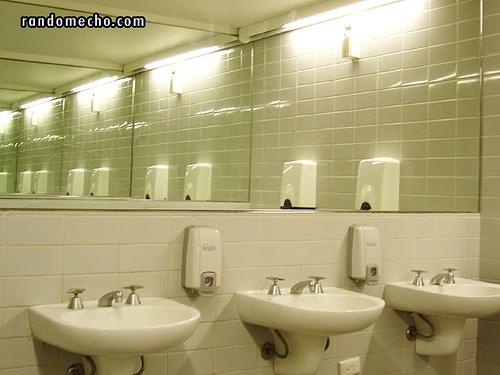How many sinks are there? Please explain your reasoning. three. There is a center sink flanked by two sinks 